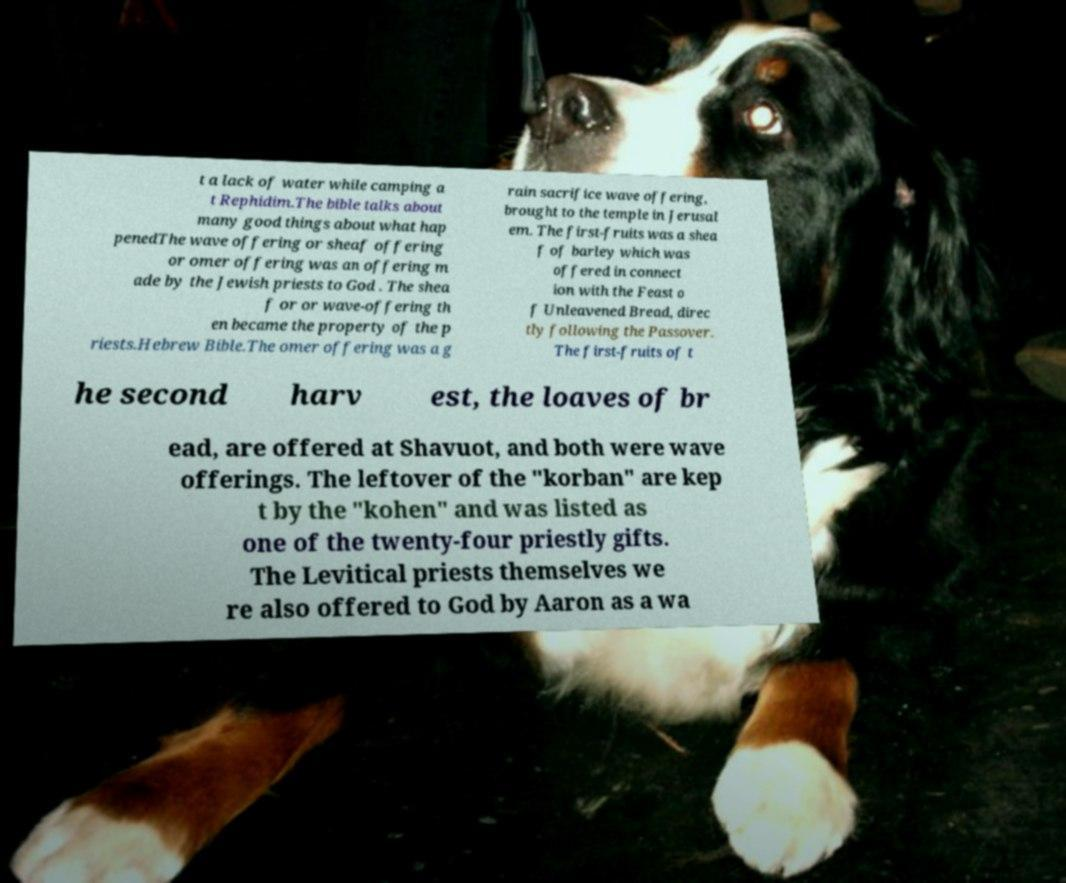Can you accurately transcribe the text from the provided image for me? t a lack of water while camping a t Rephidim.The bible talks about many good things about what hap penedThe wave offering or sheaf offering or omer offering was an offering m ade by the Jewish priests to God . The shea f or or wave-offering th en became the property of the p riests.Hebrew Bible.The omer offering was a g rain sacrifice wave offering, brought to the temple in Jerusal em. The first-fruits was a shea f of barley which was offered in connect ion with the Feast o f Unleavened Bread, direc tly following the Passover. The first-fruits of t he second harv est, the loaves of br ead, are offered at Shavuot, and both were wave offerings. The leftover of the "korban" are kep t by the "kohen" and was listed as one of the twenty-four priestly gifts. The Levitical priests themselves we re also offered to God by Aaron as a wa 